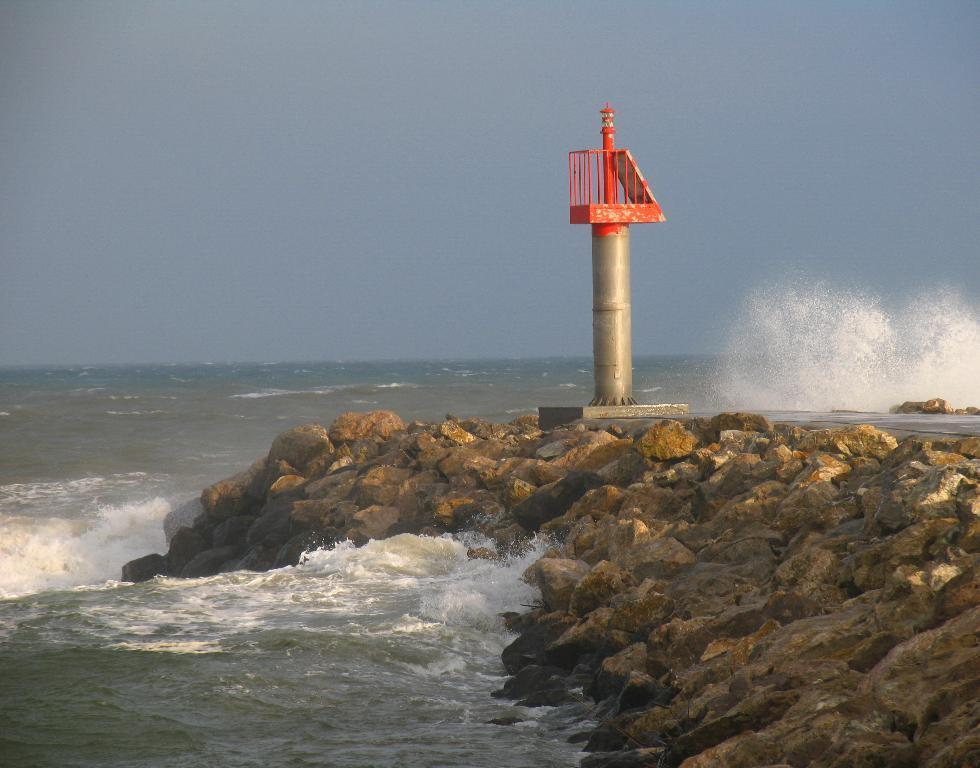What is the main feature in the center of the image? There is water in the center of the image. What can be seen in the front of the image? There are stones in the front of the image. What structure is present in the image? There is a pole in the image. What colors are visible on the pole? The pole has a silver and red color. How many eggs are visible on the pole in the image? There are no eggs present on the pole in the image. What position does the pole hold in relation to the water? The pole's position in relation to the water is not specified in the image, but it is likely near the water. 